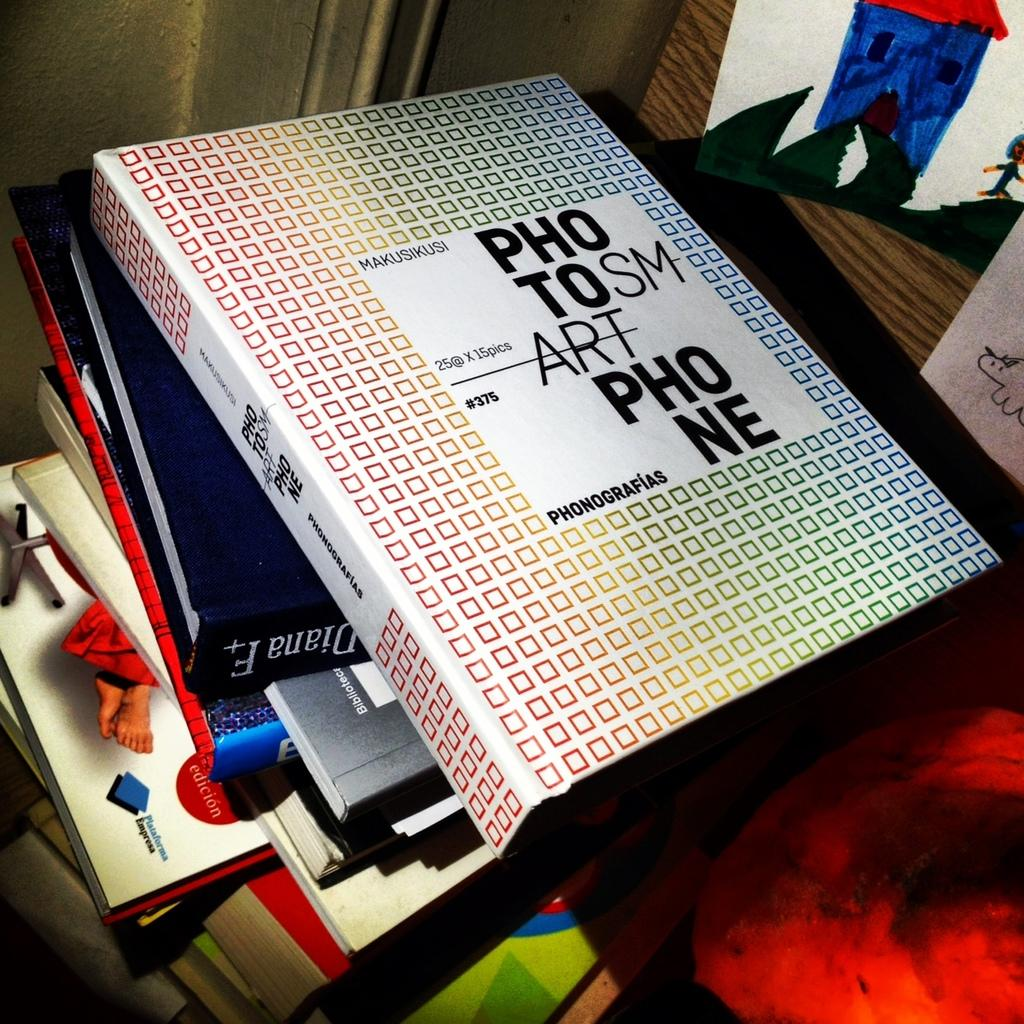<image>
Provide a brief description of the given image. a stack of books, the top one is covered in small squares with words on it photo smart phone 